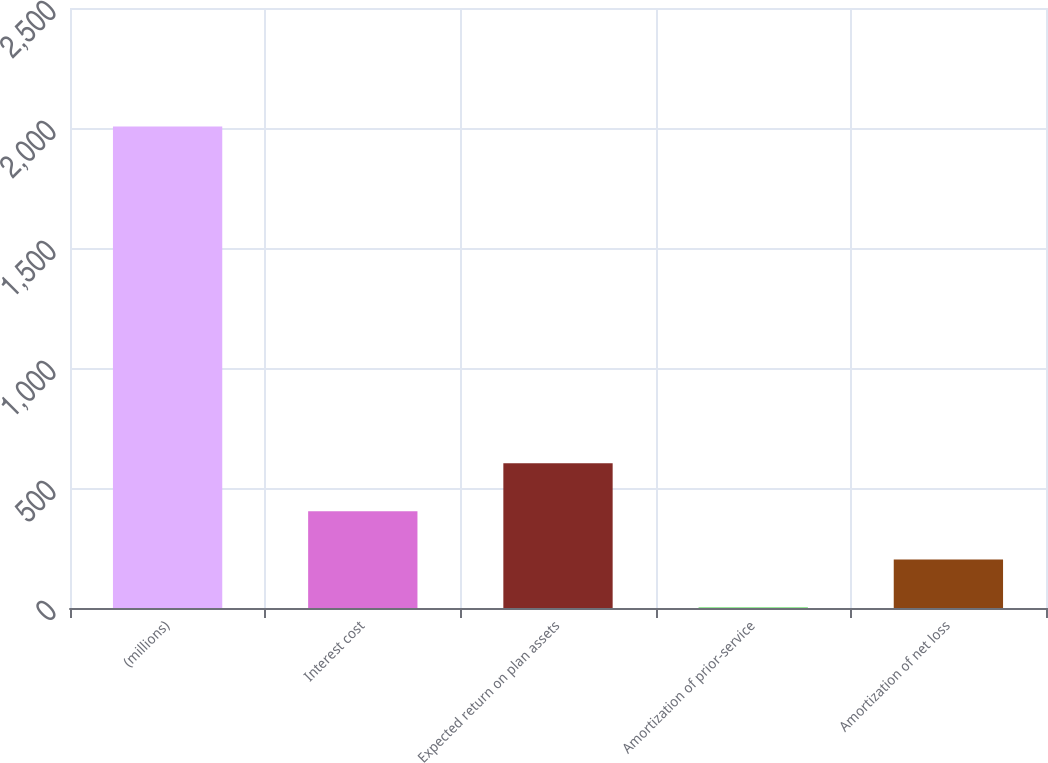Convert chart. <chart><loc_0><loc_0><loc_500><loc_500><bar_chart><fcel>(millions)<fcel>Interest cost<fcel>Expected return on plan assets<fcel>Amortization of prior-service<fcel>Amortization of net loss<nl><fcel>2006<fcel>402.8<fcel>603.2<fcel>2<fcel>202.4<nl></chart> 